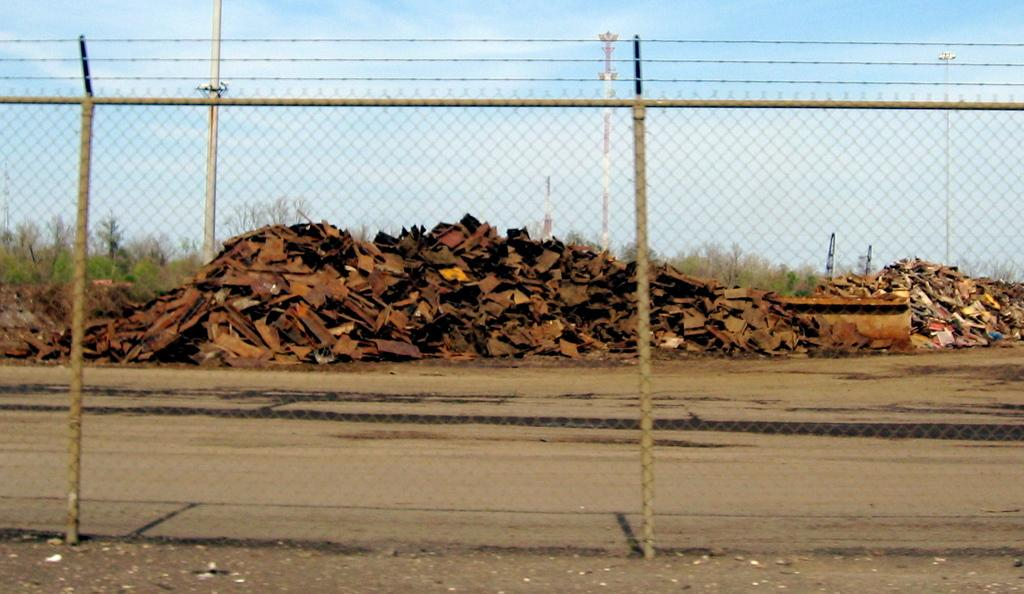What is located at the front of the image? There is a fence in the front of the image. What can be seen in the background of the image? There are trees, poles, and a scrap in the background of the image. What is the condition of the sky in the image? The sky is cloudy in the image. Can you tell me how many cats are sitting on the scrap in the image? There are no cats present in the image; it features a fence, trees, poles, and a scrap. What type of show is being performed in the image? There is no show being performed in the image; it is a scene with a fence, trees, poles, a scrap, and a cloudy sky. 